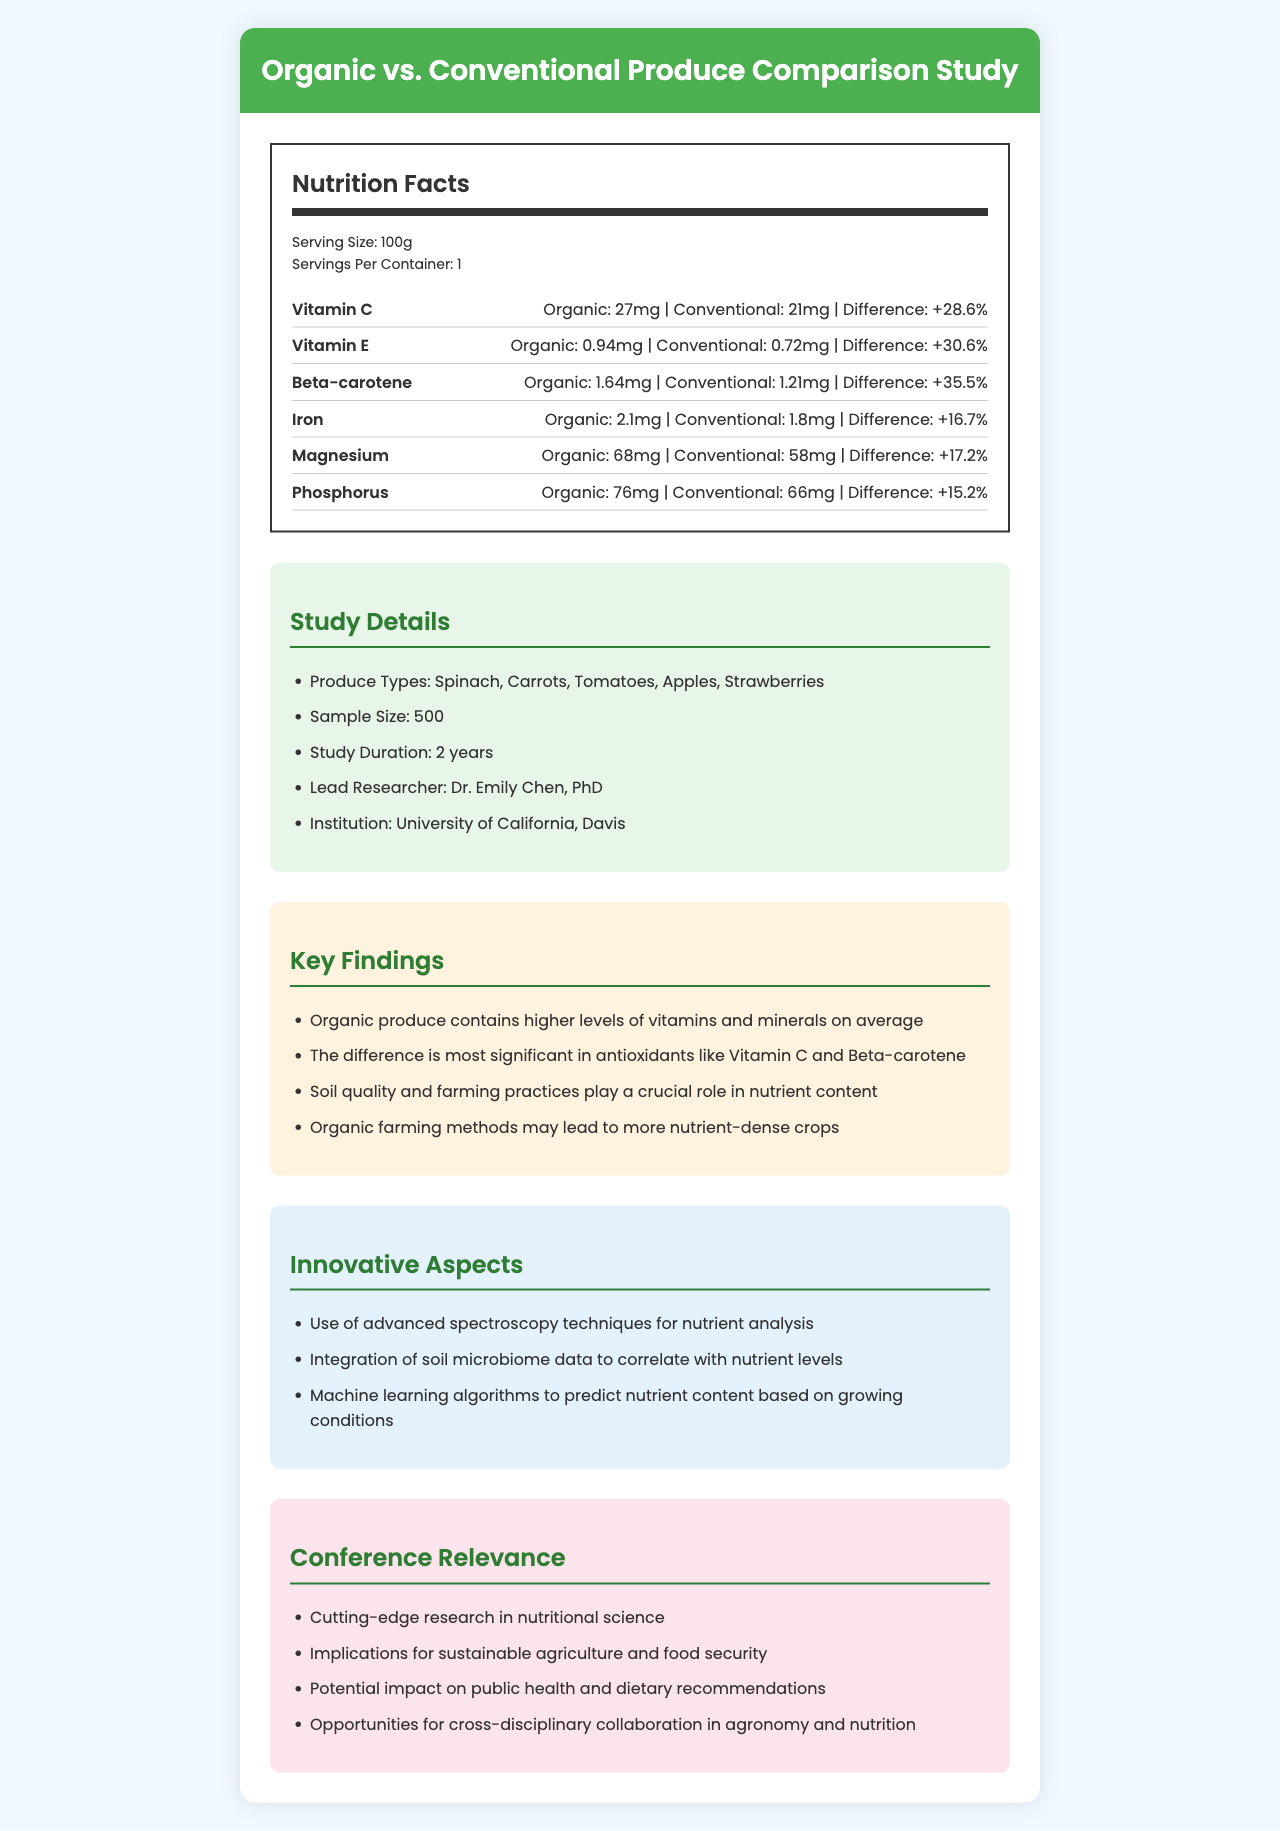what is the serving size for the produce comparison study? The document specifies that the serving size is "100g".
Answer: 100g how many servings per container are there in the study? According to the document, there is 1 serving per container.
Answer: 1 which nutrient shows the highest percentage difference between organic and conventional produce? The difference percentage for Beta-carotene is +35.5%, which is the highest among the listed nutrients.
Answer: Beta-carotene who is the lead researcher of the study? The lead researcher is named in the document as Dr. Emily Chen, PhD.
Answer: Dr. Emily Chen, PhD how long did the study last? The study duration is listed as 2 years in the document.
Answer: 2 years does organic produce contain higher levels of vitamins and minerals on average according to the findings? The key findings in the document explicitly state that "Organic produce contains higher levels of vitamins and minerals on average."
Answer: Yes what techniques were used for nutrient analysis in the study? The innovative aspects mention the use of advanced spectroscopy techniques for nutrient analysis.
Answer: Advanced spectroscopy techniques what is the sample size of the study? The document specifies a sample size of 500.
Answer: 500 summarize the main idea of the document. The main idea of the document revolves around comparing the nutritional content of organic and conventional produce, showcasing the advantages of organic farming, and emphasizing the study's innovative methodologies and broader implications for agriculture and health.
Answer: The document compares the vitamin and mineral content of organic and conventional produce based on a study showing organic produce has higher nutrient levels. It highlights significant differences, particularly in antioxidants like Vitamin C and Beta-carotene, and notes the influence of farming practices. The study uses advanced techniques and provides insights relevant to sustainable agriculture, public health, and cross-disciplinary collaboration. do organic and conventional produce have the same amount of Magnesium? Organic produce has 68mg of Magnesium, while conventional produce has 58mg, as indicated in the document.
Answer: No is Calcium content compared in the study? The document does not mention Calcium, so it cannot be determined based on the provided information.
Answer: I don't know 